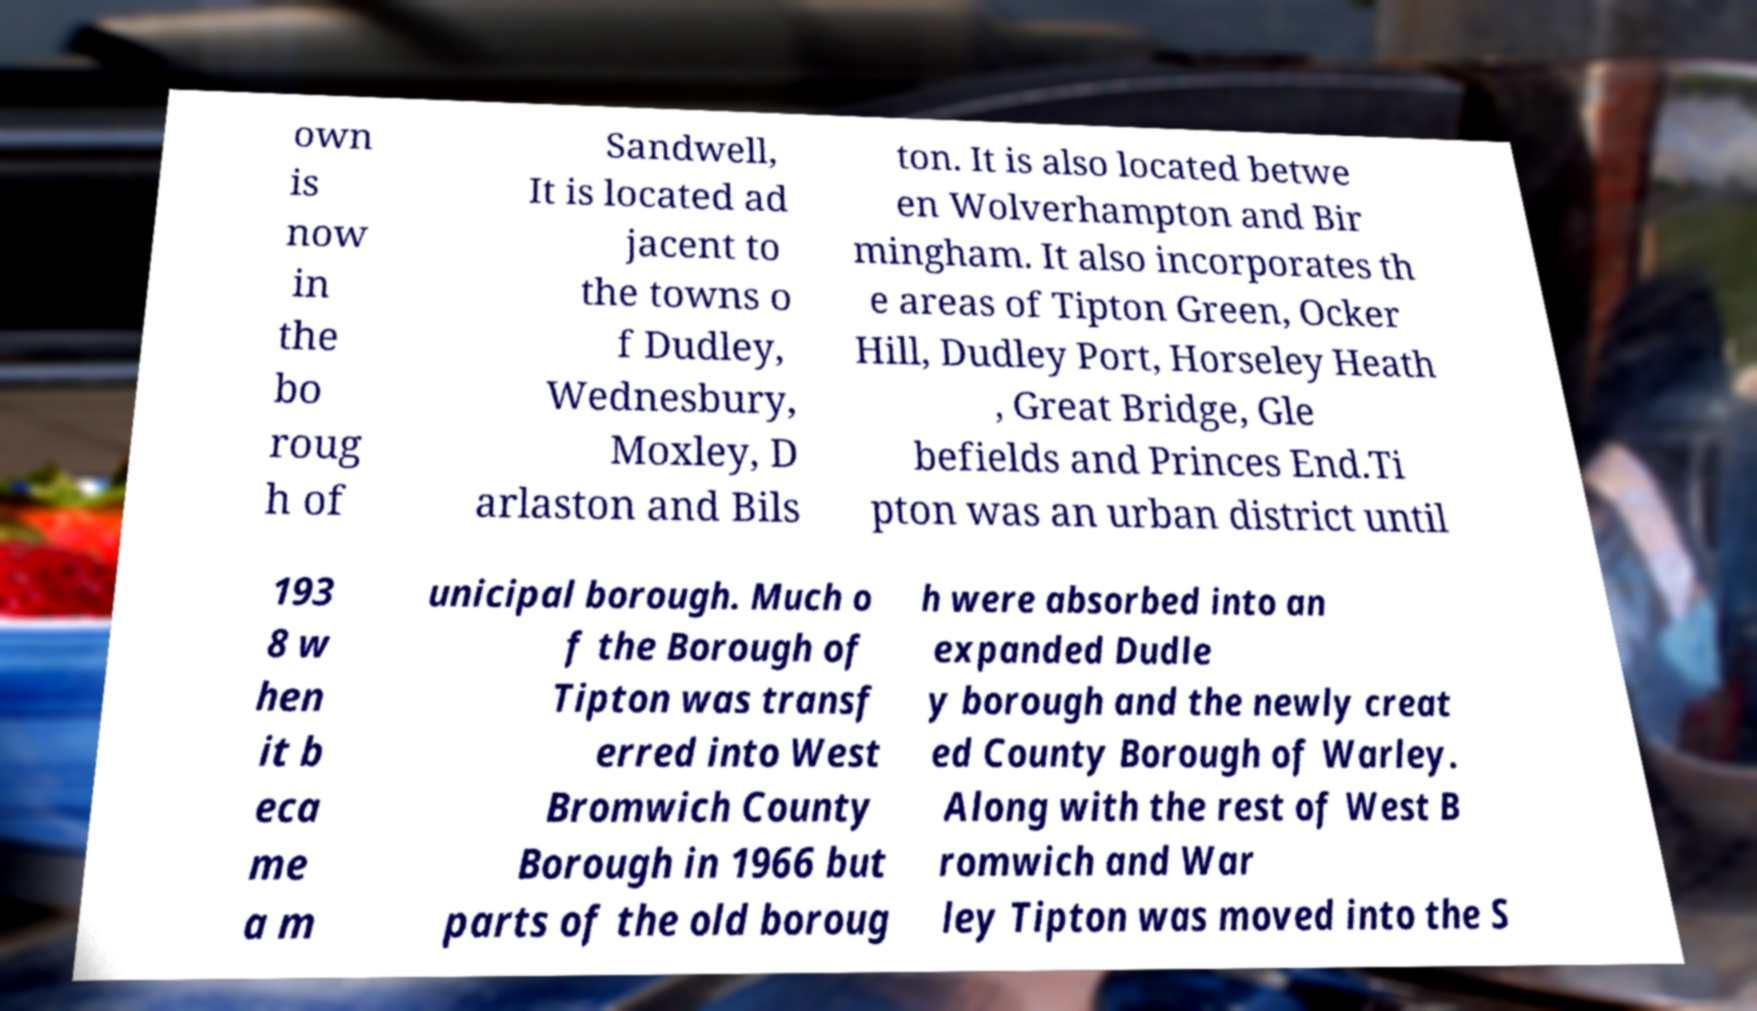Can you read and provide the text displayed in the image?This photo seems to have some interesting text. Can you extract and type it out for me? own is now in the bo roug h of Sandwell, It is located ad jacent to the towns o f Dudley, Wednesbury, Moxley, D arlaston and Bils ton. It is also located betwe en Wolverhampton and Bir mingham. It also incorporates th e areas of Tipton Green, Ocker Hill, Dudley Port, Horseley Heath , Great Bridge, Gle befields and Princes End.Ti pton was an urban district until 193 8 w hen it b eca me a m unicipal borough. Much o f the Borough of Tipton was transf erred into West Bromwich County Borough in 1966 but parts of the old boroug h were absorbed into an expanded Dudle y borough and the newly creat ed County Borough of Warley. Along with the rest of West B romwich and War ley Tipton was moved into the S 